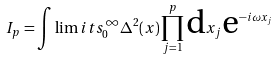Convert formula to latex. <formula><loc_0><loc_0><loc_500><loc_500>I _ { p } = \int \lim i t s _ { 0 } ^ { \infty } \Delta ^ { 2 } ( x ) \prod _ { j = 1 } ^ { p } \text {d} x _ { j } \text {e} ^ { - i \omega x _ { j } }</formula> 